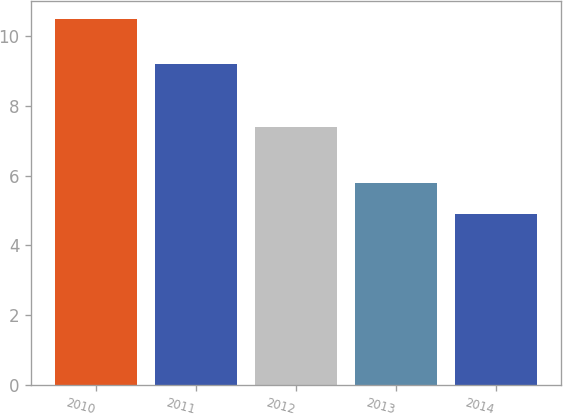Convert chart to OTSL. <chart><loc_0><loc_0><loc_500><loc_500><bar_chart><fcel>2010<fcel>2011<fcel>2012<fcel>2013<fcel>2014<nl><fcel>10.5<fcel>9.2<fcel>7.4<fcel>5.8<fcel>4.9<nl></chart> 